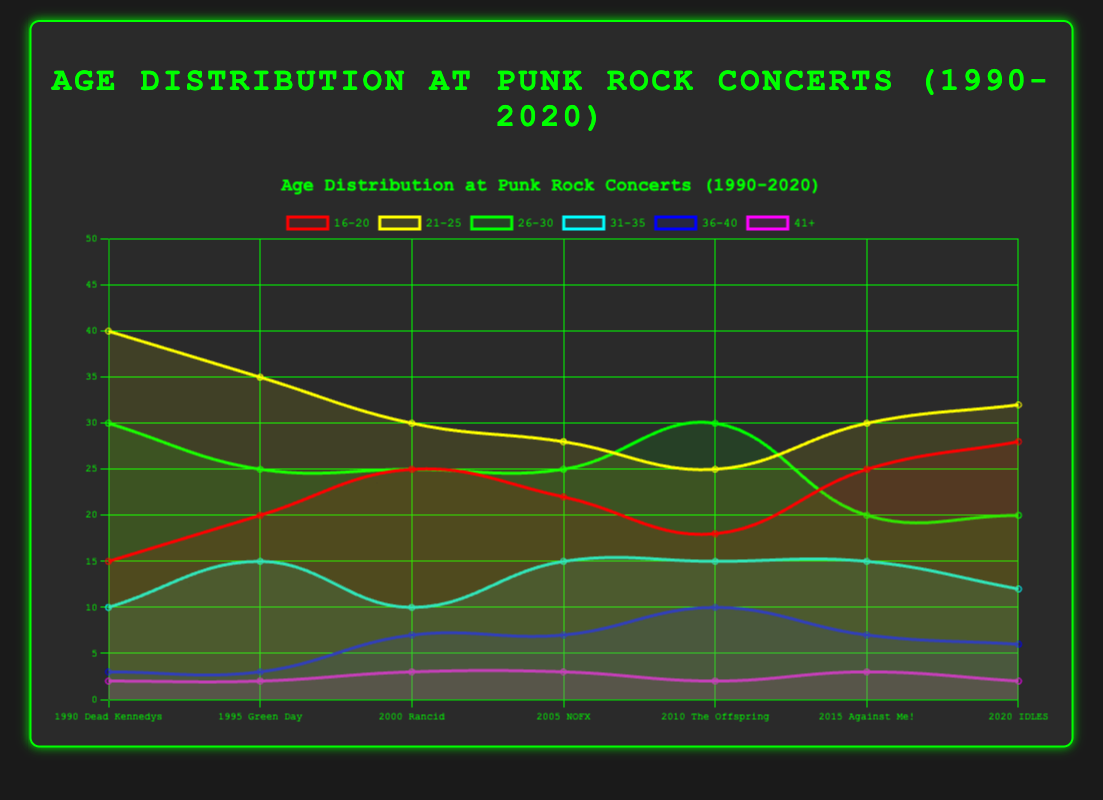What is the general trend in the age group '16-20' from 1990 to 2020? The '16-20' age group starts at 15 in 1990 and shows an increasing trend, moving to 20 in 1995, 25 in 2000, 22 in 2005, 18 in 2010, 25 in 2015, and 28 in 2020. Hence, there is a general upward trend despite some fluctuations.
Answer: Increasing Which age group had the highest attendance at the Dead Kennedys concert in 1990? The age group '21-25' had the highest attendance with a value of 40, which is greater than the values for other age groups.
Answer: 21-25 How does the distribution for the age group '41+' change from 1990 to 2020? The '41+' age group remains relatively stable at low values, starting from 2 in 1990 and remaining at 2 in 1995, 3 in 2000, 3 in 2005, 2 in 2010, 3 in 2015, and 2 again in 2020.
Answer: Relatively stable Which age group had the smallest attendance at the concert in 2010 and what was the value? The age group '41+' had the smallest attendance in 2010 with a value of 2.
Answer: 41+, 2 What is the average attendance for the age group '26-30' over the decades? Summing the values for '26-30' from 1990 to 2020: (30 + 25 + 25 + 25 + 30 + 20 + 20) = 175. There are 7 data points, hence the average is 175 / 7 = 25.
Answer: 25 In which year did the age group '36-40' see the highest attendance, and what was the value? The '36-40' age group saw the highest attendance in 2010 with a value of 10.
Answer: 2010, 10 How does the attendance of the '21-25' age group at IDLES concert in 2020 compare to the attendance of the same group at the Green Day concert in 1995? The '21-25' age group attendance at the IDLES concert in 2020 was 32, which is less than the attendance for the same group at the Green Day concert in 1995, which was 35.
Answer: Less Which age group has the most stable attendance over the three decades and why? The '41+' age group has the most stable attendance with values closely hovering around 2-3 from 1990 to 2020. This stability is evident compared to other age groups which show more fluctuation over the years.
Answer: 41+ What is the total increase in attendance for the age group '16-20' from 1990 to 2020? The initial value for '16-20' was 15 in 1990 and increased to 28 in 2020. The total increase is 28 - 15 = 13.
Answer: 13 Which band attracted the oldest demographic in 2000? In 2000, the largest attendance for older age groups (41+) was by the band Rancid, with an attendance of 3.
Answer: Rancid 